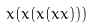Convert formula to latex. <formula><loc_0><loc_0><loc_500><loc_500>x ( x ( x ( x x ) ) )</formula> 